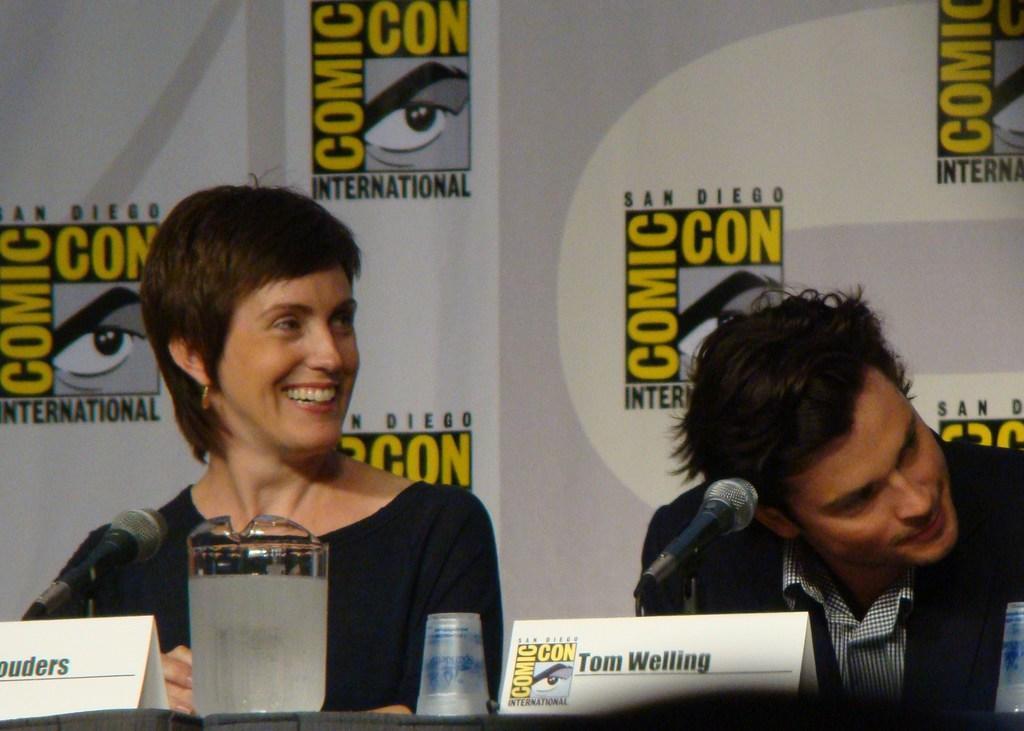Can you describe this image briefly? On the right side of the image we can see a man is sitting and wearing a suit. On the left side of the image we can see a lady is sitting and smiling. At the bottom of the image we can see a table. On the table we can see the boards, glasses, mics with stands. In the background of the image we can see a board. 